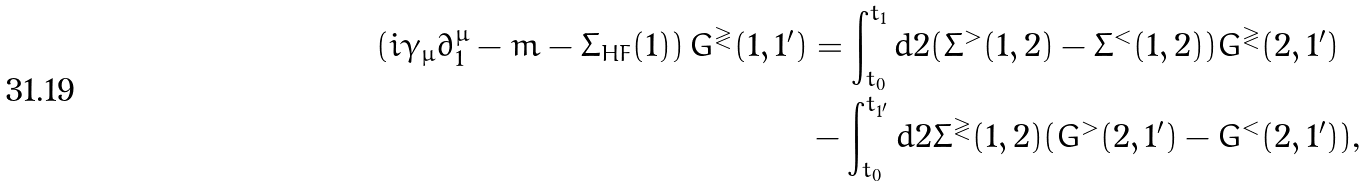Convert formula to latex. <formula><loc_0><loc_0><loc_500><loc_500>\left ( i \gamma _ { \mu } \partial _ { 1 } ^ { \mu } - m - \Sigma _ { H F } ( 1 ) \right ) G ^ { \gtrless } ( 1 , 1 ^ { \prime } ) & = \int _ { t _ { 0 } } ^ { t _ { 1 } } d 2 ( \Sigma ^ { > } ( 1 , 2 ) - \Sigma ^ { < } ( 1 , 2 ) ) G ^ { \gtrless } ( 2 , 1 ^ { \prime } ) \\ & - \int _ { t _ { 0 } } ^ { t _ { 1 ^ { \prime } } } d 2 \Sigma ^ { \gtrless } ( 1 , 2 ) ( G ^ { > } ( 2 , 1 ^ { \prime } ) - G ^ { < } ( 2 , 1 ^ { \prime } ) ) \text {,}</formula> 